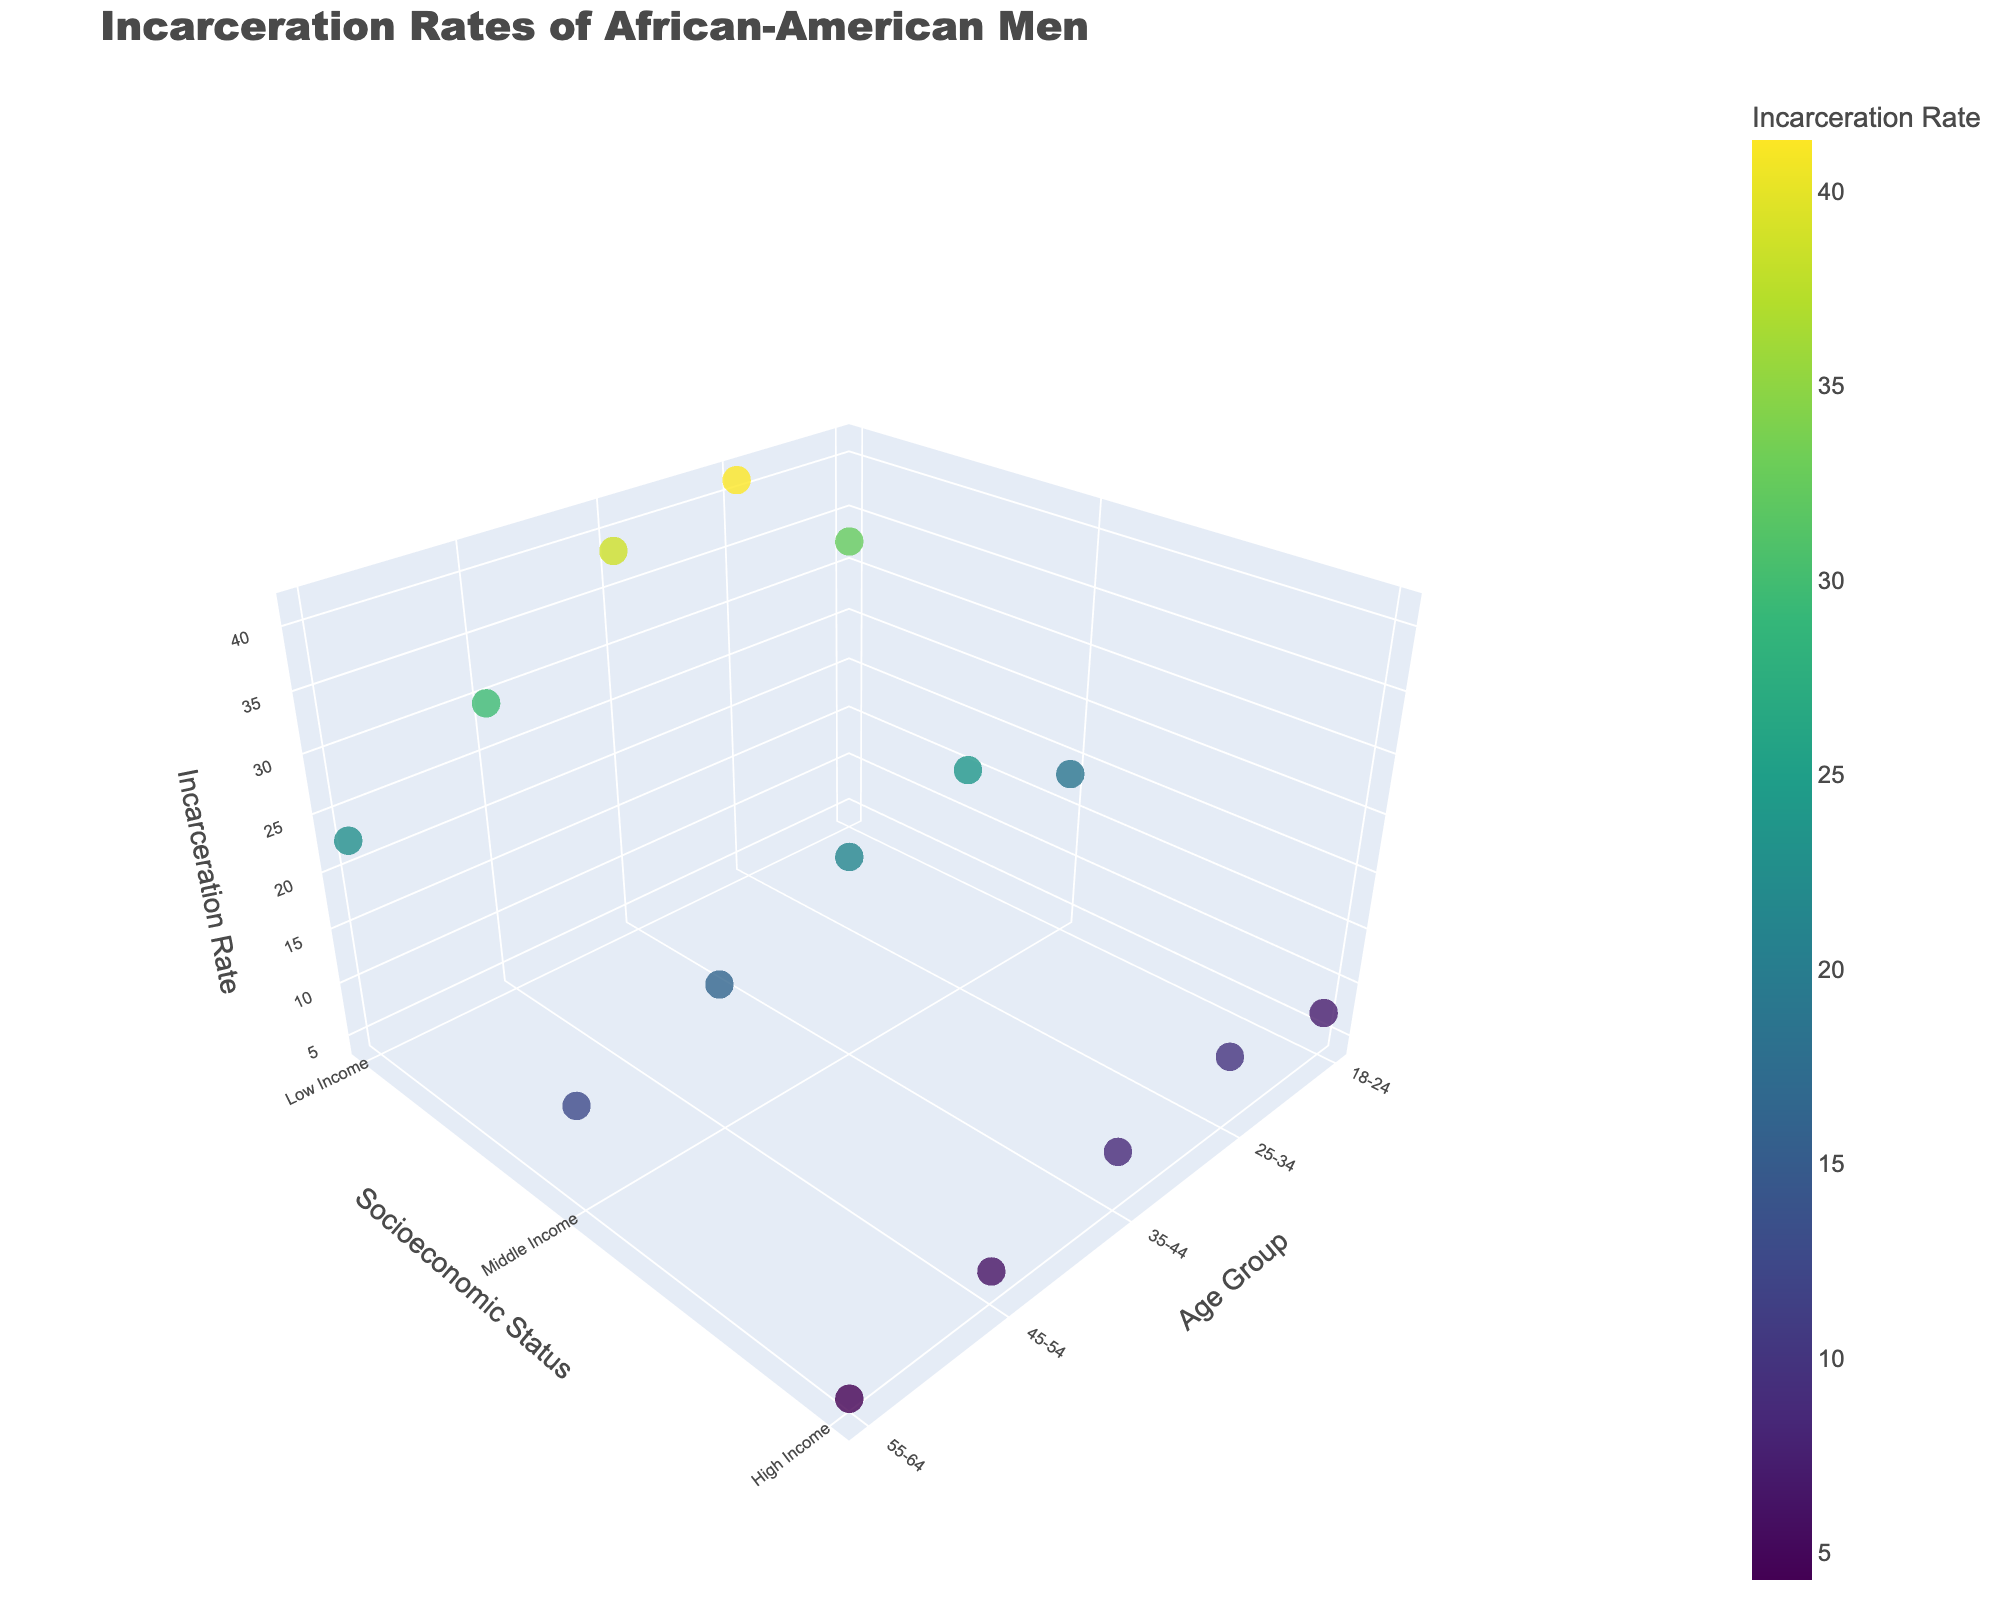What is the title of the plot? The title of the plot is displayed prominently at the top. It is written in a larger font size compared to other text elements.
Answer: Incarceration Rates of African-American Men What is the Incarceration Rate for high-income men in the age group 25-34 in Chicago? Locate the data points on the plot corresponding to high-income men in the 25-34 age group in Chicago. The z-axis will provide the Incarceration Rate.
Answer: 9.8 Which age group has the highest incarceration rate across all cities? Examine the z-axis values for all the data points across different age groups. Identify the highest value and find the corresponding age group.
Answer: 25-34 How does the incarceration rate of low-income men aged 18-24 in Atlanta compare to that of middle-income men in the same city and age group? Identify the data points for low-income and middle-income men aged 18-24 in Atlanta. Compare the values on the z-axis.
Answer: 32.5 is higher than 18.7 What city has the lowest incarceration rate for high-income men in the 35-44 age group? Find the data points on the plot for high-income men in the 35-44 age group. Identify the city associated with the lowest z-axis value among them.
Answer: Detroit What is the average incarceration rate for middle-income men across all age groups and cities? Sum the incarceration rates for middle-income men across all age groups and cities and divide by the number of these data points. The data points are: Atlanta, Chicago, Detroit, Baltimore, and New Orleans.
Answer: (18.7 + 23.9 + 21.4 + 16.2 + 12.5) / 5 = 18.54 Which socioeconomic status group has the most variation in incarceration rates for the 45-54 age group? Compare the range of incarceration rates (maximum value - minimum value) within the low-income, middle-income, and high-income groups for the 45-54 age group.
Answer: Low Income In which city do you observe the highest incarceration rate for any one group, and which group is it? Survey the plot for the data point with the highest z-axis value and identify the corresponding city and group.
Answer: Chicago, Low Income, 25-34 age group How does the incarceration rate for men aged 55-64 in New Orleans compare across different socioeconomic statuses? Locate the data points for men aged 55-64 in New Orleans on the plot. Compare the incarceration rates for low-income, middle-income, and high-income groups.
Answer: Low Income: 22.8; Middle Income: 12.5; High Income: 4.3 